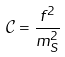Convert formula to latex. <formula><loc_0><loc_0><loc_500><loc_500>\mathcal { C } = { \frac { f ^ { 2 } } { m _ { S } ^ { 2 } } }</formula> 